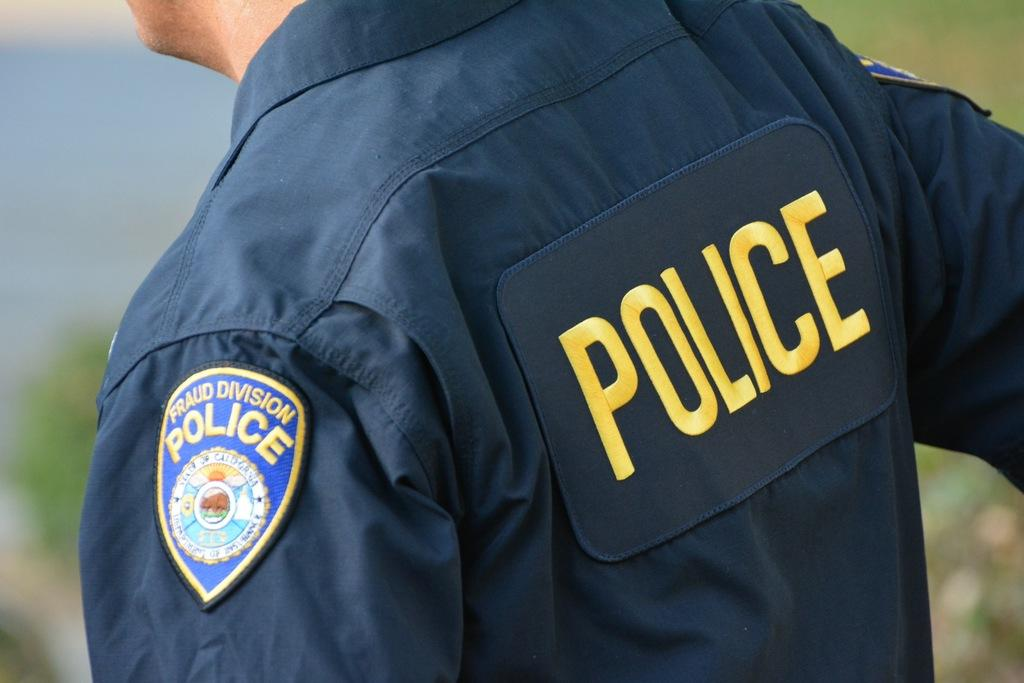<image>
Render a clear and concise summary of the photo. A police officer has a badge on his left shoulder named Fraud Division Police. 